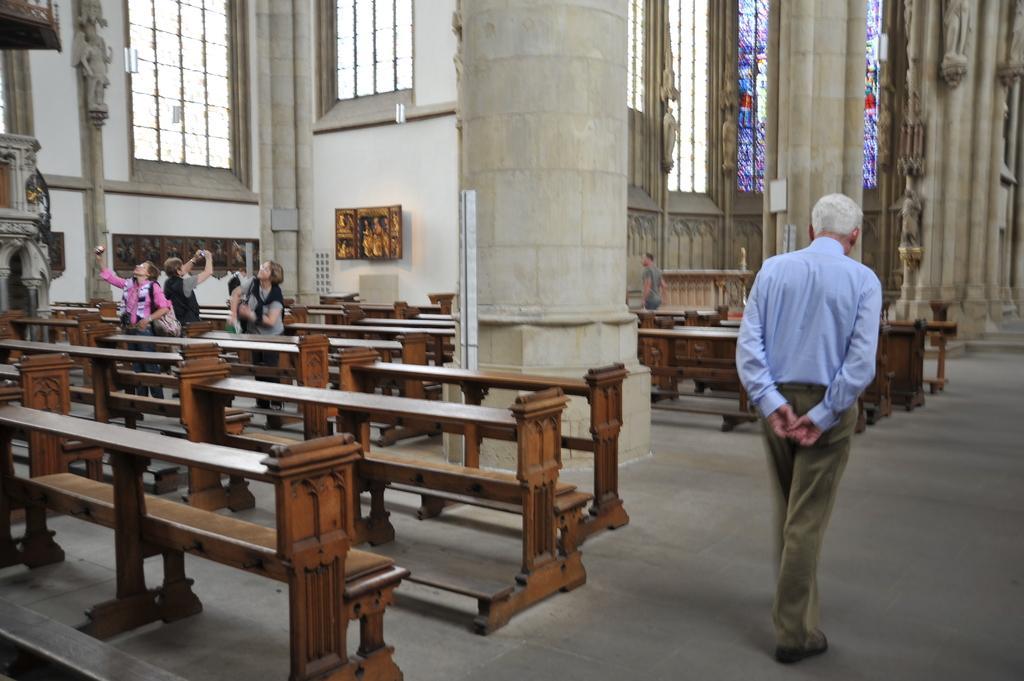Could you give a brief overview of what you see in this image? As we can see in the image there is a white color wall, photo frame and few benches over here and there is a man walking. 